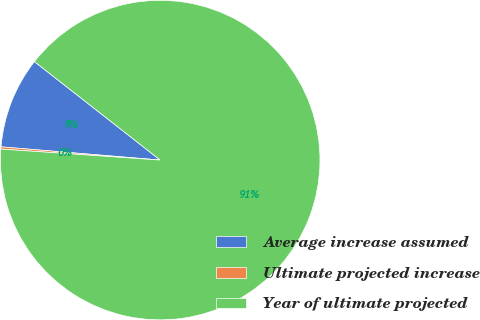<chart> <loc_0><loc_0><loc_500><loc_500><pie_chart><fcel>Average increase assumed<fcel>Ultimate projected increase<fcel>Year of ultimate projected<nl><fcel>9.25%<fcel>0.22%<fcel>90.53%<nl></chart> 